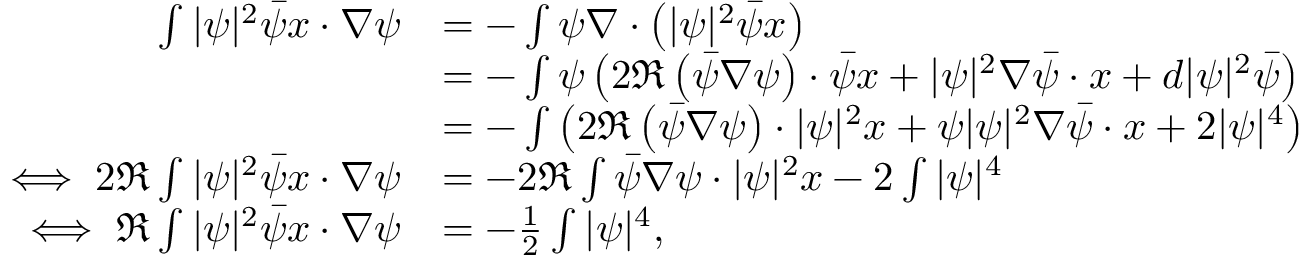<formula> <loc_0><loc_0><loc_500><loc_500>\begin{array} { r l } { \int | \psi | ^ { 2 } \bar { \psi } x \cdot \nabla \psi } & { = - \int \psi \nabla \cdot \left ( | \psi | ^ { 2 } \bar { \psi } x \right ) } \\ & { = - \int \psi \left ( 2 \Re \left ( \bar { \psi } \nabla \psi \right ) \cdot \bar { \psi } x + | \psi | ^ { 2 } \nabla \bar { \psi } \cdot x + d | \psi | ^ { 2 } \bar { \psi } \right ) } \\ & { = - \int \left ( 2 \Re \left ( \bar { \psi } \nabla \psi \right ) \cdot | \psi | ^ { 2 } x + \psi | \psi | ^ { 2 } \nabla \bar { \psi } \cdot x + 2 | \psi | ^ { 4 } \right ) } \\ { \iff 2 \Re \int | \psi | ^ { 2 } \bar { \psi } x \cdot \nabla \psi } & { = - 2 \Re \int \bar { \psi } \nabla \psi \cdot | \psi | ^ { 2 } x - 2 \int | \psi | ^ { 4 } } \\ { \iff \Re \int | \psi | ^ { 2 } \bar { \psi } x \cdot \nabla \psi } & { = - \frac { 1 } { 2 } \int | \psi | ^ { 4 } , } \end{array}</formula> 